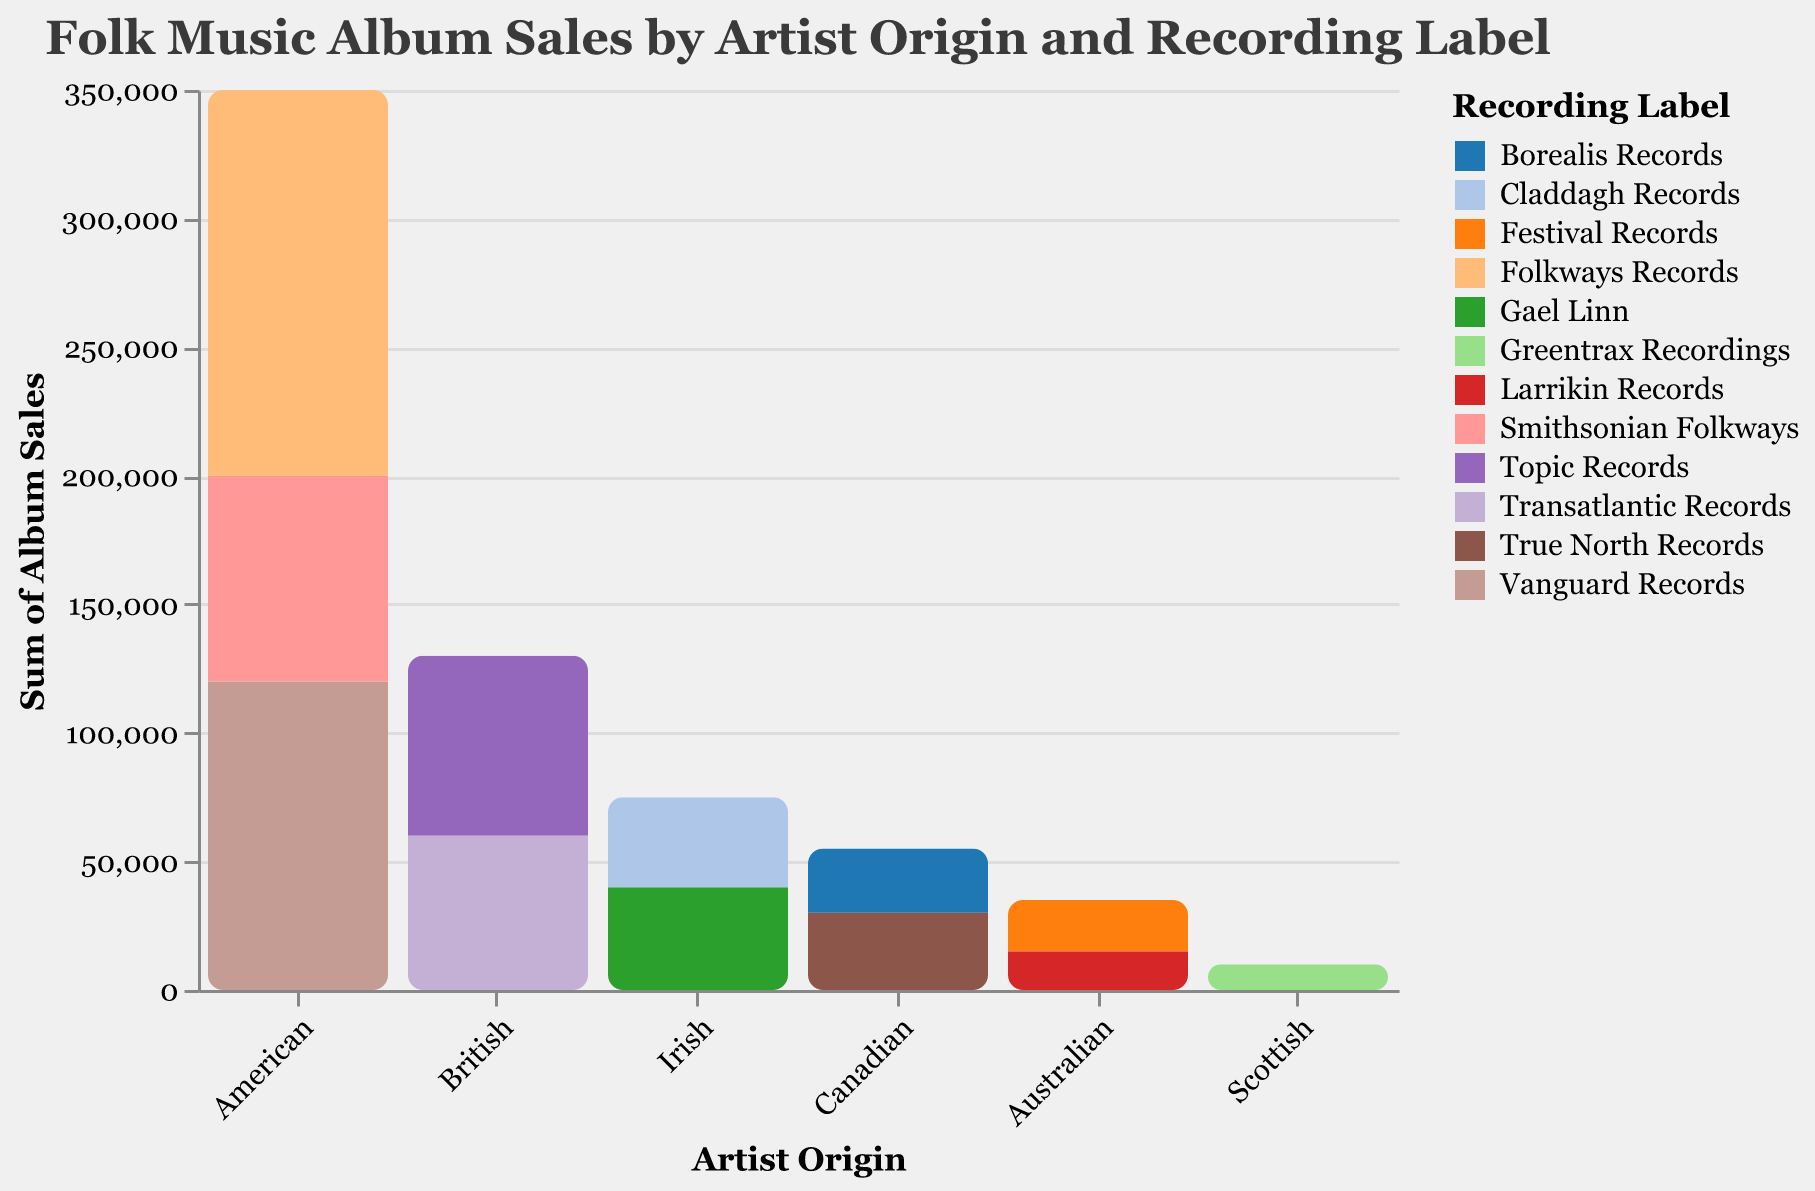What is the total number of album sales for American artists? To find the total number of album sales for American artists, sum up the sales for Folkways Records, Vanguard Records, and Smithsonian Folkways. (150000 + 120000 + 80000) = 350000
Answer: 350000 Which recording label has the highest album sales for American artists? Compare the album sales for each American recording label: Folkways Records (150000), Vanguard Records (120000), and Smithsonian Folkways (80000). Folkways Records has the highest sales.
Answer: Folkways Records How do the album sales of Irish artists compare to Canadian artists? Sum the album sales for Irish artists (Gael Linn: 40000, Claddagh Records: 35000) and Canadian artists (True North Records: 30000, Borealis Records: 25000) separately. Compare the sums: Irish (75000), Canadian (55000). Irish artists have higher sales.
Answer: Irish artists have higher sales Which artist origin has the lowest album sales and what is the total? Look at the total album sales represented in the plot for each artist origin and determine which is the lowest. Scottish artists have the lowest, with Greentrax Recordings at 10000.
Answer: Scottish, 10000 Which recording label has the highest total album sales overall? Compare the total album sales for each recording label across all artist origins. Folkways Records (150000) has the highest sales.
Answer: Folkways Records What are the total album sales for British artists, and how do they compare to Australian artists? Sum the album sales for British (Topic Records: 70000, Transatlantic Records: 60000) and Australian artists (Festival Records: 20000, Larrikin Records: 15000) separately. Compare the sums: British (130000), Australian (35000). British artists have significantly higher sales.
Answer: British: 130000; Australian: 35000 What is the average album sales per recording label for American artists? Sum the album sales for American artists (Folkways Records: 150000, Vanguard Records: 120000, Smithsonian Folkways: 80000) and divide by the number of labels (3). (350000 / 3) = 116666.67
Answer: 116666.67 Among Canadian artists, which recording label has higher album sales, and by how much? Compare the album sales of True North Records (30000) and Borealis Records (25000). True North Records has higher sales by (30000 - 25000) = 5000.
Answer: True North Records, 5000 What is the difference in total album sales between British artists and Irish artists? Sum the album sales for British artists (130000) and Irish artists (75000). Subtract the totals: (130000 - 75000) = 55000. British artists have 55000 more in sales.
Answer: 55000 What proportion of total album sales is represented by Australian artists? Sum the total album sales across all artist origins (750000), then find the proportion for Australian artists (35000). (35000 / 750000) = 0.0467 or 4.67%.
Answer: 4.67% 